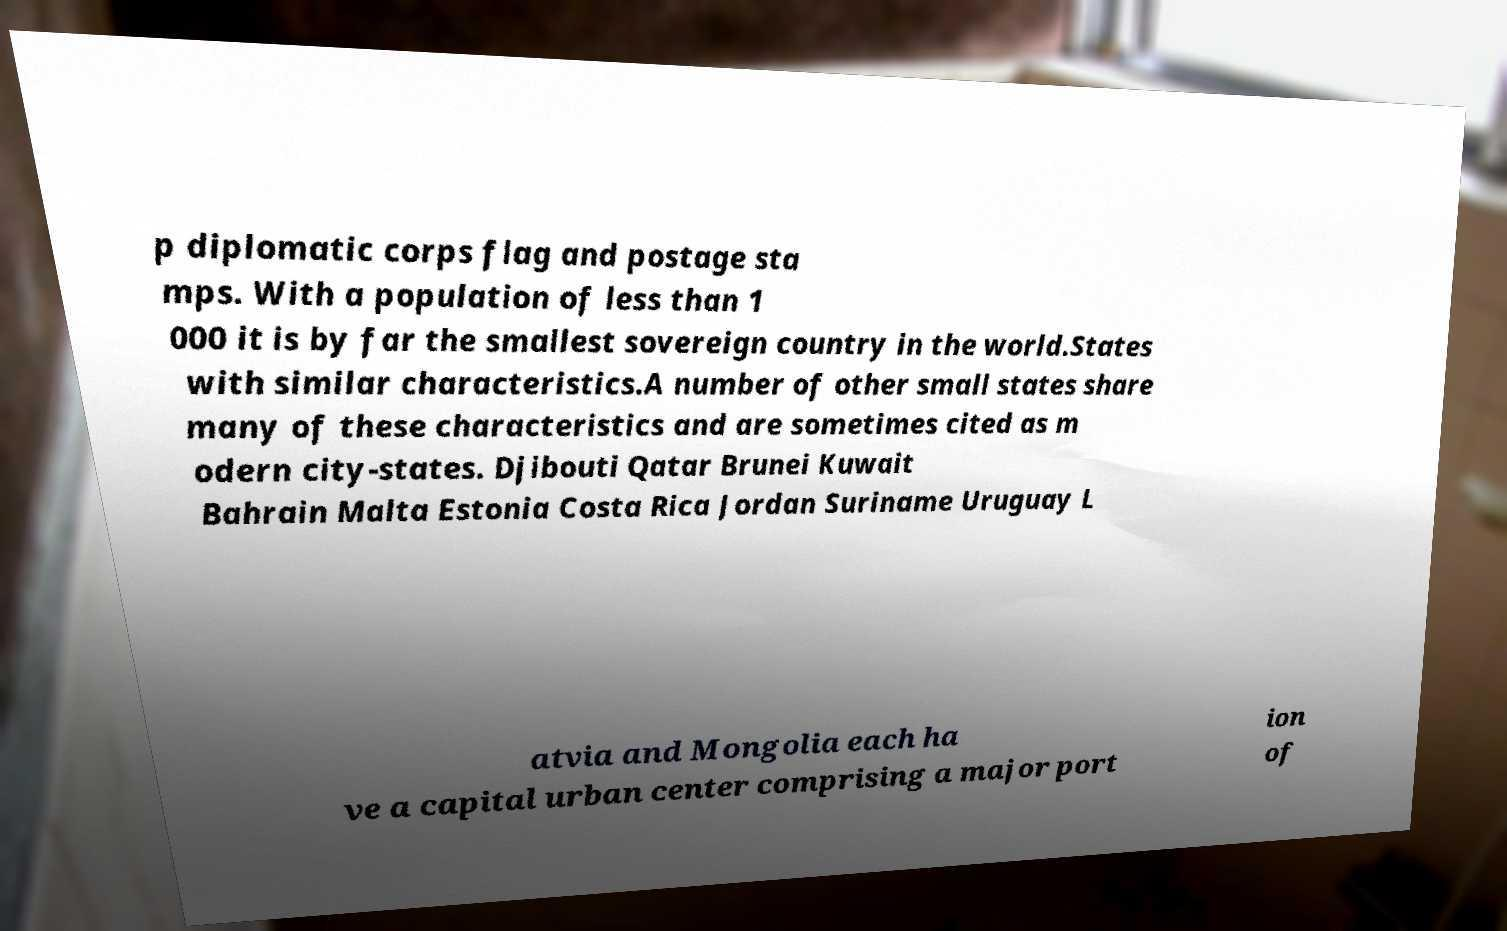Could you assist in decoding the text presented in this image and type it out clearly? p diplomatic corps flag and postage sta mps. With a population of less than 1 000 it is by far the smallest sovereign country in the world.States with similar characteristics.A number of other small states share many of these characteristics and are sometimes cited as m odern city-states. Djibouti Qatar Brunei Kuwait Bahrain Malta Estonia Costa Rica Jordan Suriname Uruguay L atvia and Mongolia each ha ve a capital urban center comprising a major port ion of 